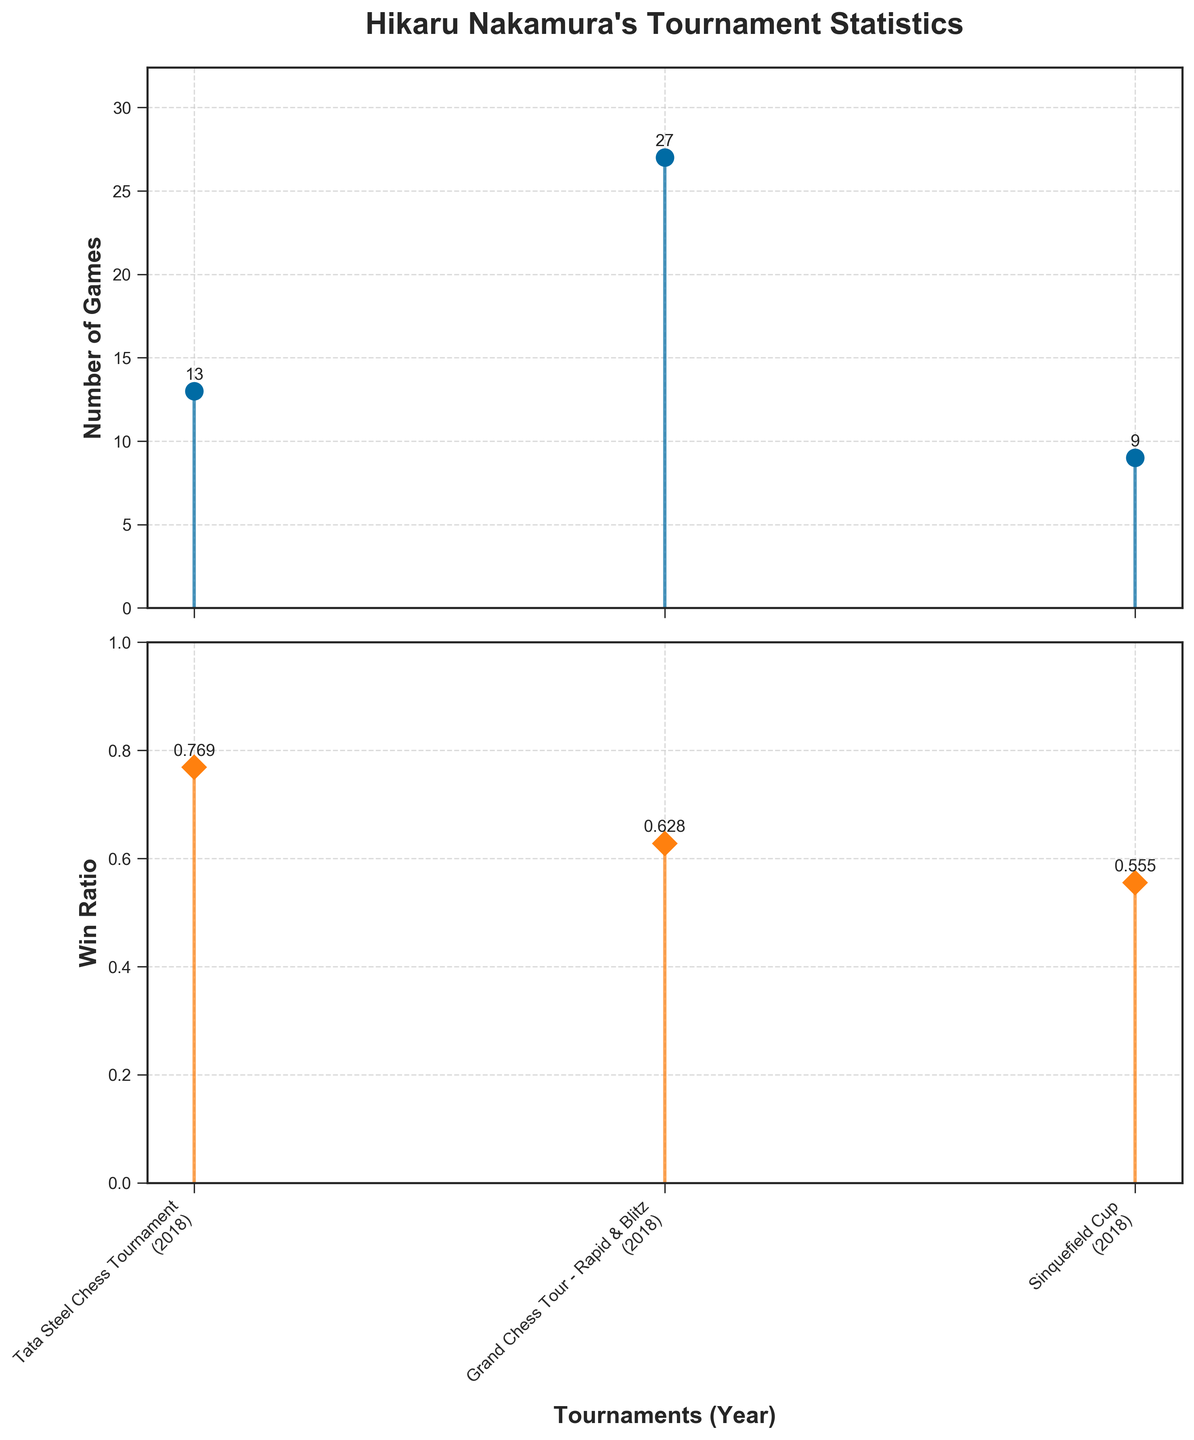What's the title of the figure? The title of the figure is presented at the top of the first subplot. It is written in a larger and bold font for prominence.
Answer: Hikaru Nakamura's Tournament Statistics How many tournaments are represented in the plot? By counting the x-axis labels in both subplots, we can see that there are three tournaments represented.
Answer: 3 Which tournament had the highest number of games played? By comparing the stems in the first subplot, the tallest stem represents the tournament with the highest number of games. Accordingly, the "Grand Chess Tour - Rapid & Blitz" tournament has the tallest stem.
Answer: Grand Chess Tour - Rapid & Blitz What is the win ratio for the Sinquefield Cup tournament? In the second subplot, locate the stem corresponding to "Sinquefield Cup". The annotation on top of the stem provides the exact win ratio.
Answer: 0.555 What is the combined number of games played across all tournaments? Sum the number of games played in each tournament: 13 (Tata Steel Chess Tournament) + 27 (Grand Chess Tour - Rapid & Blitz) + 9 (Sinquefield Cup).
Answer: 49 Which tournament had the lowest win ratio, and what is the number of games played in that tournament? By comparing the heights and annotations of the stems in the second subplot, the "Sinquefield Cup" has the lowest win ratio of 0.555. The corresponding number of games played can be found in the first subplot, which is 9.
Answer: Sinquefield Cup, 9 How do the win ratios of the Tata Steel Chess Tournament and the Grand Chess Tour - Rapid & Blitz compare? Look at the annotations on the stems of the second subplot for both tournaments. The win ratios are 0.769 for the Tata Steel Chess Tournament and 0.628 for the Grand Chess Tour - Rapid & Blitz.
Answer: Tata Steel Chess Tournament has a higher win ratio What is the average win ratio across all the tournaments? Calculate the mean of the win ratios: (0.769 + 0.628 + 0.555)/3.
Answer: 0.651 In which year did these tournaments occur, and where is this information displayed in the plot? The x-axis labels in the second subplot include both the tournament names and the years in parentheses. All tournaments occurred in 2018, as displayed beside the tournament names.
Answer: 2018, beside the tournament names What is the difference in the number of games played between the tournament with the highest and lowest games played? Subtract the number of games played in the Sinquefield Cup (9) from that in the Grand Chess Tour - Rapid & Blitz (27).
Answer: 18 